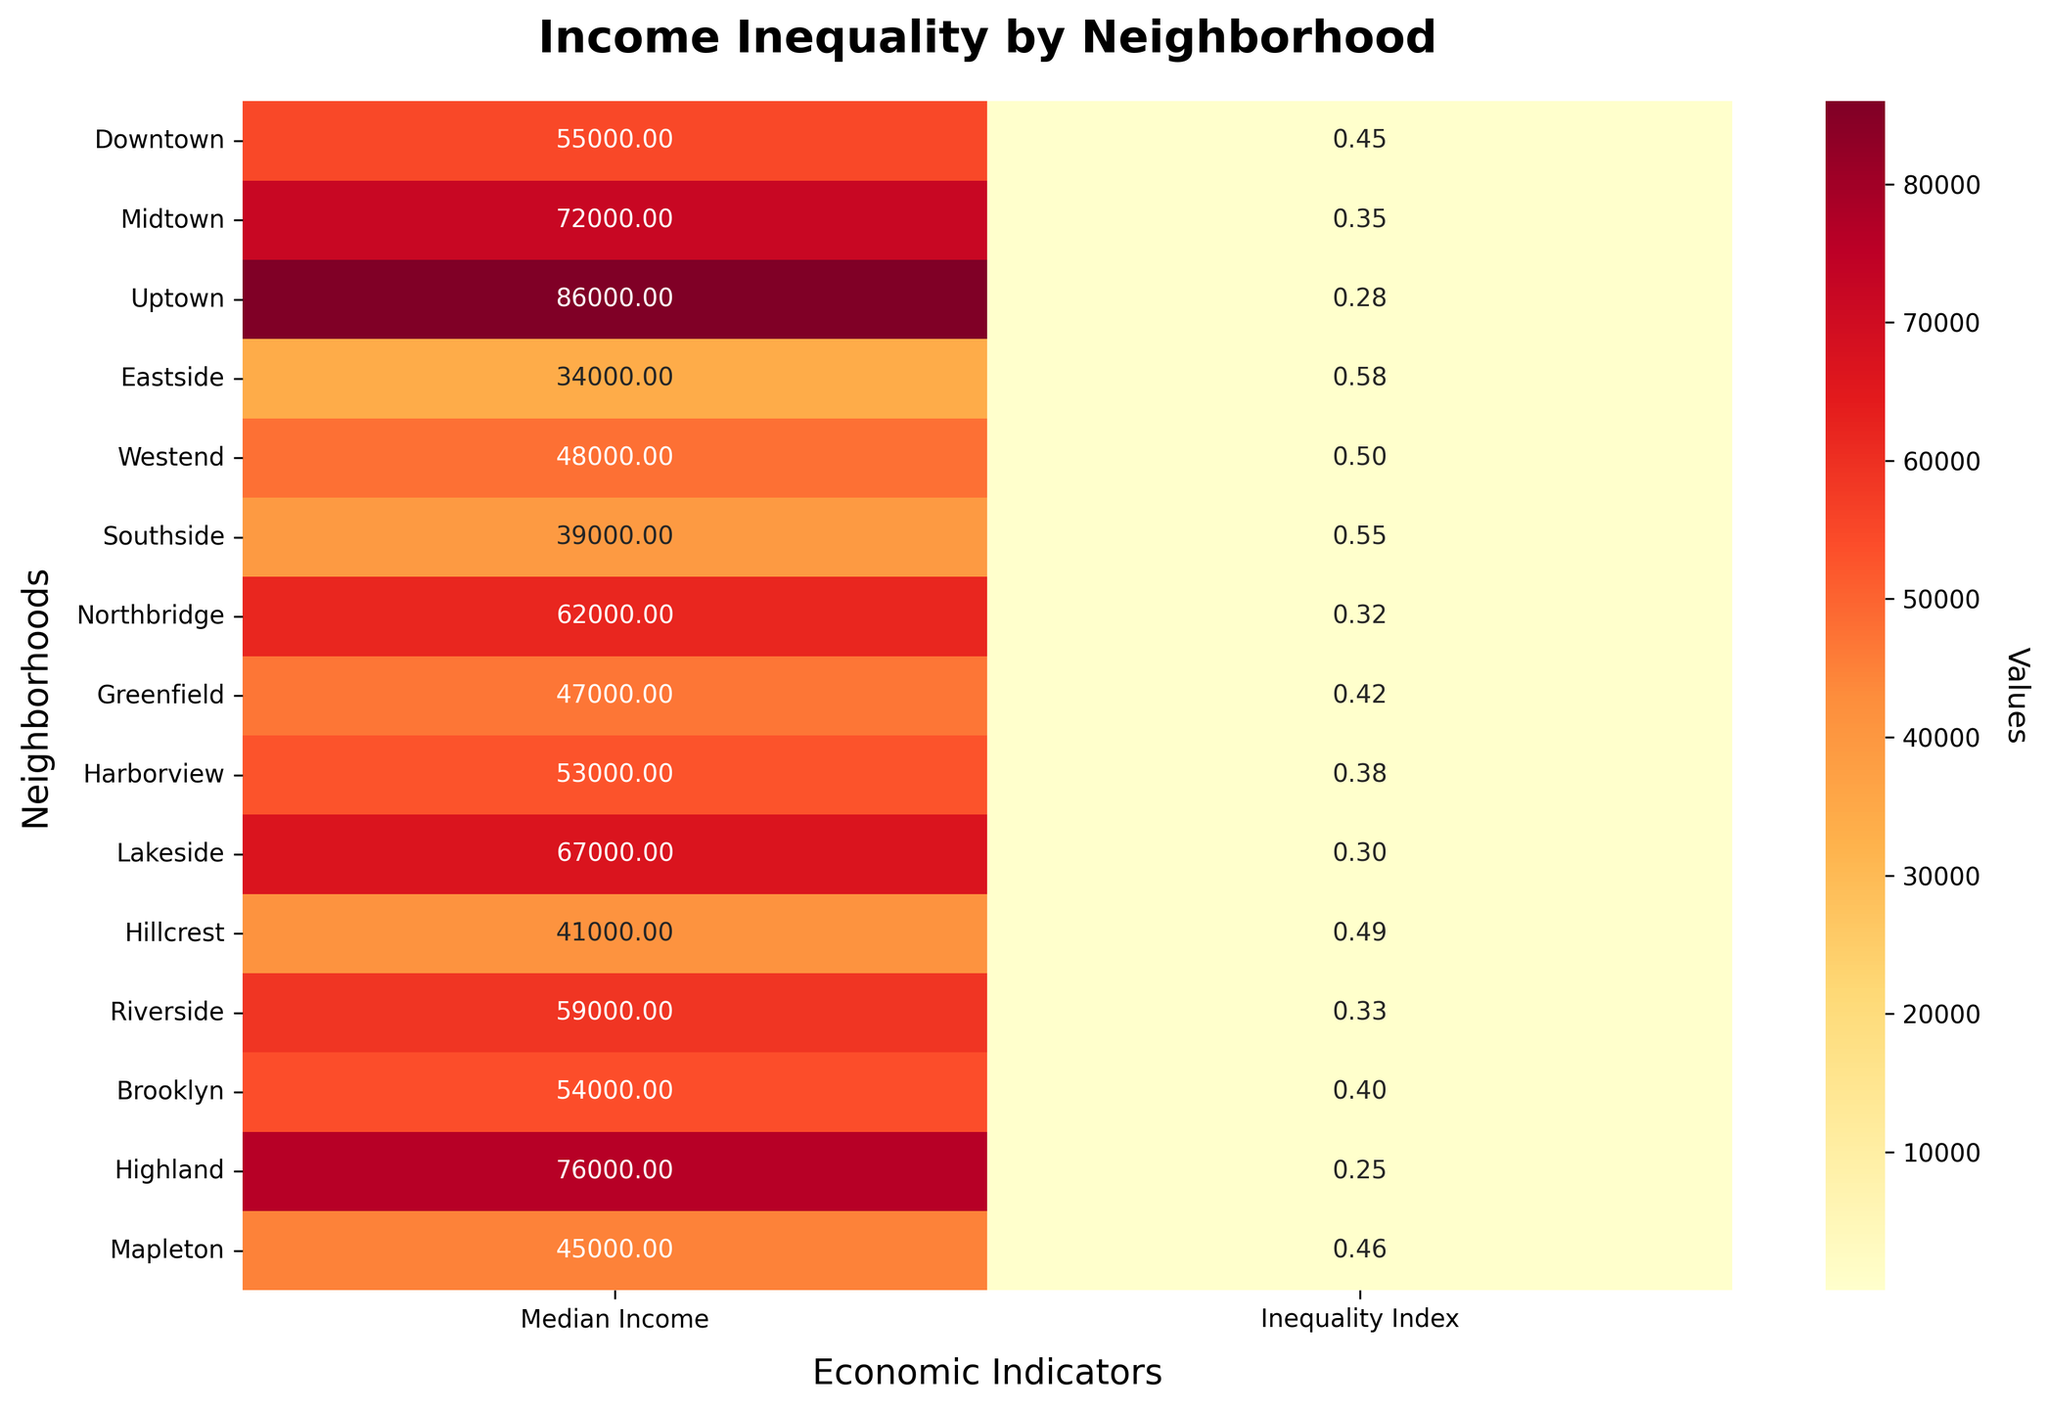What is the title of the heatmap? The title is written at the top of the heatmap. It states the main subject of the visualization, which is 'Income Inequality by Neighborhood'.
Answer: Income Inequality by Neighborhood What are the labels on the x-axis of the heatmap? The x-axis labels indicate the type of economic indicators being plotted. These labels can be seen below the heatmap. There are two types: 'Median Income' and 'Inequality Index'.
Answer: Median Income, Inequality Index Which neighborhood has the highest Median Income? To find the neighborhood with the highest Median Income, look at the first column of the heatmap under 'Median Income' and identify the maximum value. The highest value is in the Uptown row.
Answer: Uptown Which neighborhood has the lowest Income Inequality Index? Check the second column of the heatmap under 'Inequality Index' and locate the lowest value. The neighborhood with the lowest value is Highland.
Answer: Highland How does the Median Income of Eastside compare to that of Lakeside? Look at the values in the 'Median Income' column. Eastside has a value of 34,000 and Lakeside has a value of 67,000. Compare these two numbers.
Answer: Eastside has a lower Median Income than Lakeside Which two neighborhoods have similar Income Inequality Index values? To find similar values, compare the numbers under 'Inequality Index'. Midtown and Northbridge have similar values, 0.35 and 0.32 respectively.
Answer: Midtown and Northbridge What is the difference in Income Inequality Index between Downtown and Southside? Check the 'Inequality Index' values for both neighborhoods. Downtown's value is 0.45 and Southside's value is 0.55. Subtract 0.45 from 0.55 to get the difference.
Answer: 0.10 What is the average Median Income of Northbridge and Harborview? Add the 'Median Income' values for Northbridge (62,000) and Harborview (53,000). The sum is 115,000. Divide this by 2 to get the average.
Answer: 57,500 How many neighborhoods have a Median Income above 60,000? Examine the 'Median Income' column and count all the neighborhoods with values greater than 60,000. They are Midtown, Uptown, Northbridge, Lakeside, Highland, and Riverside, totaling 6 neighborhoods.
Answer: 6 What can you infer about the relationship between Median Income and Income Inequality Index from the heatmap? Generally, higher Median Income tends to align with lower Income Inequality Index values. For instance, Highland has the highest Median Income of 76,000 and the lowest Inequality Index of 0.25, while Eastside has the lowest Median Income of 34,000 and a higher Inequality Index of 0.58. This suggests a potential negative correlation.
Answer: Higher Median Income often corresponds to a lower Income Inequality Index 